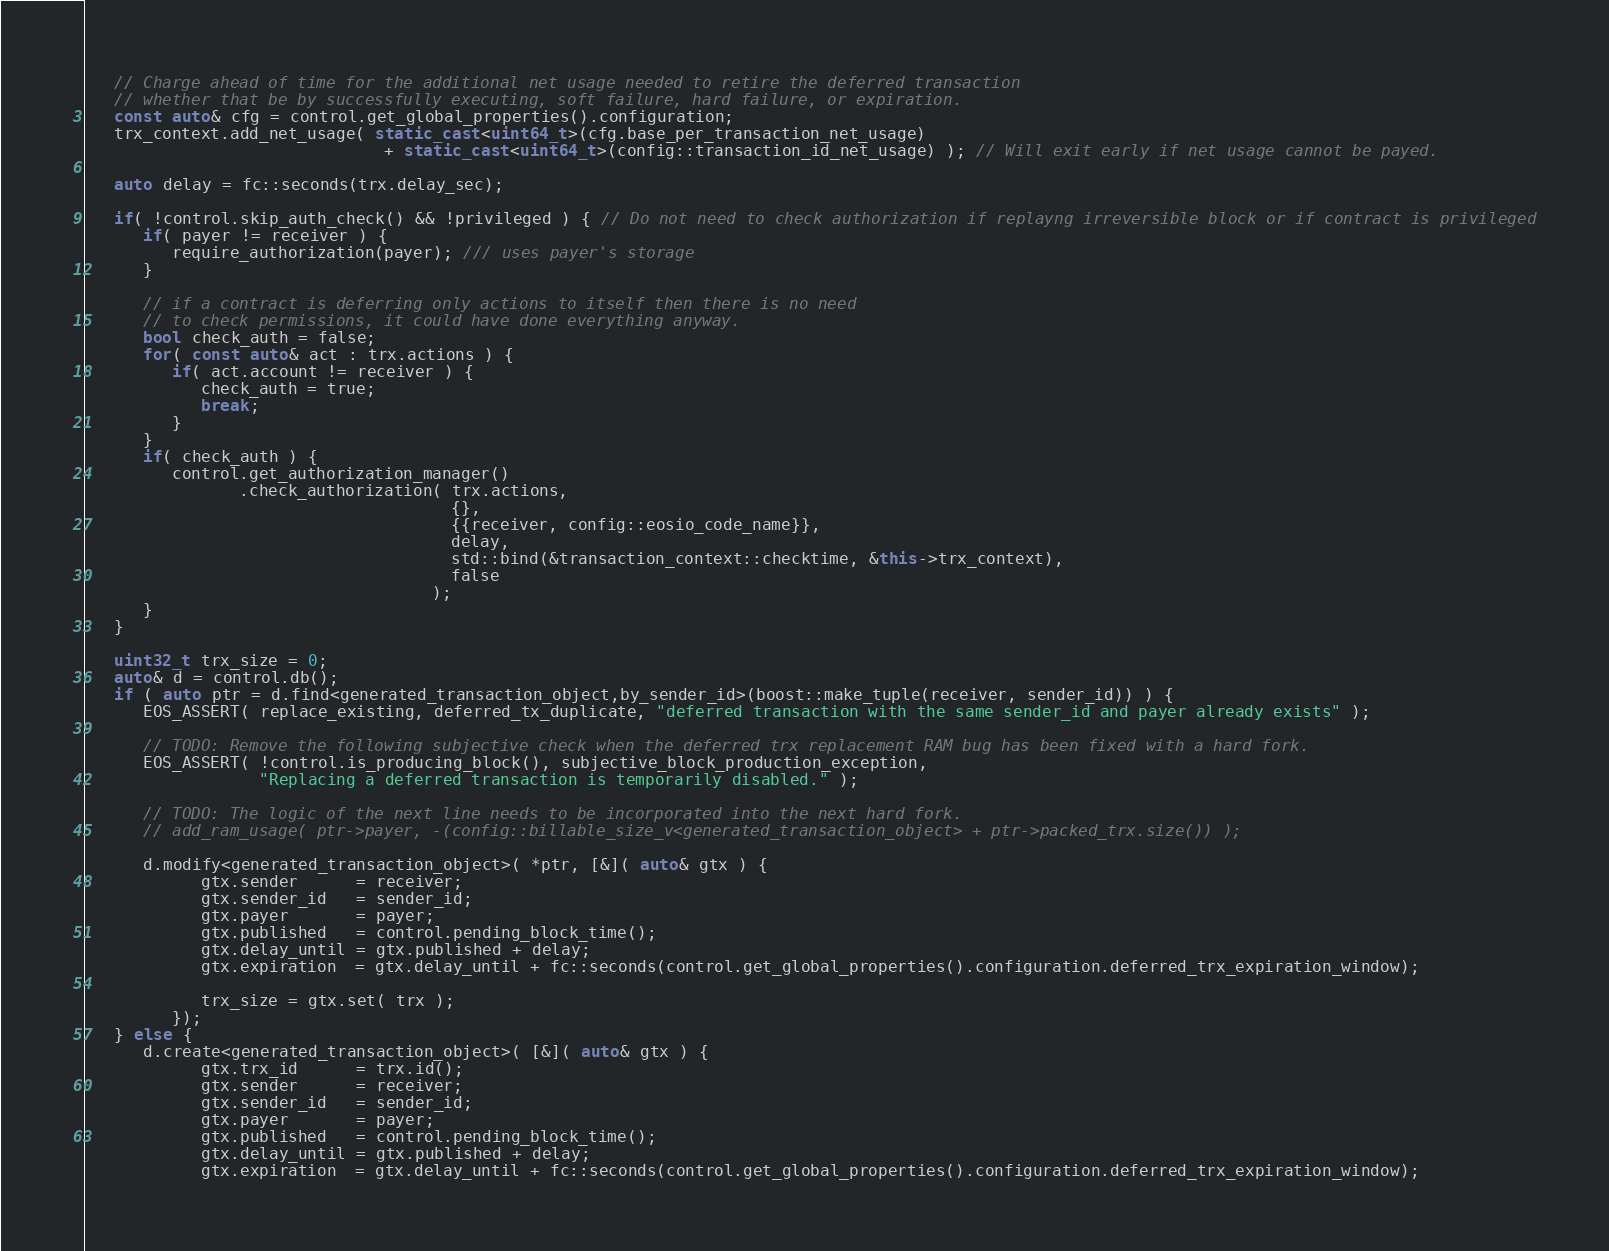Convert code to text. <code><loc_0><loc_0><loc_500><loc_500><_C++_>
   // Charge ahead of time for the additional net usage needed to retire the deferred transaction
   // whether that be by successfully executing, soft failure, hard failure, or expiration.
   const auto& cfg = control.get_global_properties().configuration;
   trx_context.add_net_usage( static_cast<uint64_t>(cfg.base_per_transaction_net_usage)
                               + static_cast<uint64_t>(config::transaction_id_net_usage) ); // Will exit early if net usage cannot be payed.

   auto delay = fc::seconds(trx.delay_sec);

   if( !control.skip_auth_check() && !privileged ) { // Do not need to check authorization if replayng irreversible block or if contract is privileged
      if( payer != receiver ) {
         require_authorization(payer); /// uses payer's storage
      }

      // if a contract is deferring only actions to itself then there is no need
      // to check permissions, it could have done everything anyway.
      bool check_auth = false;
      for( const auto& act : trx.actions ) {
         if( act.account != receiver ) {
            check_auth = true;
            break;
         }
      }
      if( check_auth ) {
         control.get_authorization_manager()
                .check_authorization( trx.actions,
                                      {},
                                      {{receiver, config::eosio_code_name}},
                                      delay,
                                      std::bind(&transaction_context::checktime, &this->trx_context),
                                      false
                                    );
      }
   }

   uint32_t trx_size = 0;
   auto& d = control.db();
   if ( auto ptr = d.find<generated_transaction_object,by_sender_id>(boost::make_tuple(receiver, sender_id)) ) {
      EOS_ASSERT( replace_existing, deferred_tx_duplicate, "deferred transaction with the same sender_id and payer already exists" );

      // TODO: Remove the following subjective check when the deferred trx replacement RAM bug has been fixed with a hard fork.
      EOS_ASSERT( !control.is_producing_block(), subjective_block_production_exception,
                  "Replacing a deferred transaction is temporarily disabled." );

      // TODO: The logic of the next line needs to be incorporated into the next hard fork.
      // add_ram_usage( ptr->payer, -(config::billable_size_v<generated_transaction_object> + ptr->packed_trx.size()) );

      d.modify<generated_transaction_object>( *ptr, [&]( auto& gtx ) {
            gtx.sender      = receiver;
            gtx.sender_id   = sender_id;
            gtx.payer       = payer;
            gtx.published   = control.pending_block_time();
            gtx.delay_until = gtx.published + delay;
            gtx.expiration  = gtx.delay_until + fc::seconds(control.get_global_properties().configuration.deferred_trx_expiration_window);

            trx_size = gtx.set( trx );
         });
   } else {
      d.create<generated_transaction_object>( [&]( auto& gtx ) {
            gtx.trx_id      = trx.id();
            gtx.sender      = receiver;
            gtx.sender_id   = sender_id;
            gtx.payer       = payer;
            gtx.published   = control.pending_block_time();
            gtx.delay_until = gtx.published + delay;
            gtx.expiration  = gtx.delay_until + fc::seconds(control.get_global_properties().configuration.deferred_trx_expiration_window);
</code> 